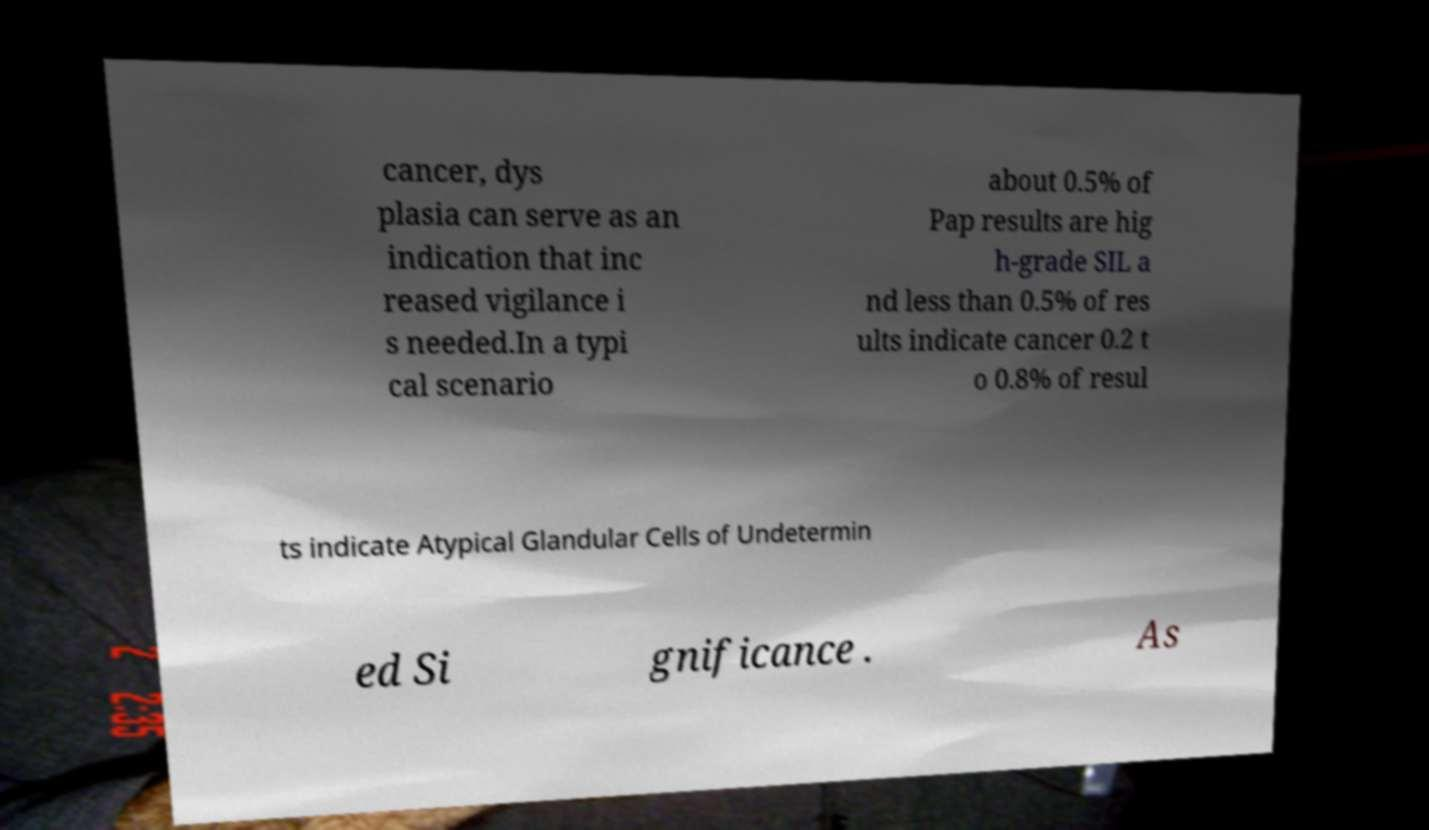Please read and relay the text visible in this image. What does it say? cancer, dys plasia can serve as an indication that inc reased vigilance i s needed.In a typi cal scenario about 0.5% of Pap results are hig h-grade SIL a nd less than 0.5% of res ults indicate cancer 0.2 t o 0.8% of resul ts indicate Atypical Glandular Cells of Undetermin ed Si gnificance . As 